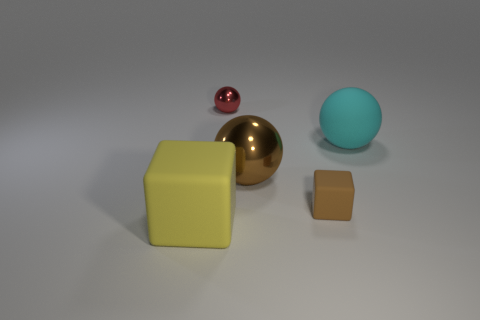Add 4 tiny red things. How many objects exist? 9 Subtract all blocks. How many objects are left? 3 Subtract 0 yellow cylinders. How many objects are left? 5 Subtract all big brown spheres. Subtract all cyan rubber objects. How many objects are left? 3 Add 1 big cyan matte objects. How many big cyan matte objects are left? 2 Add 1 large cyan matte objects. How many large cyan matte objects exist? 2 